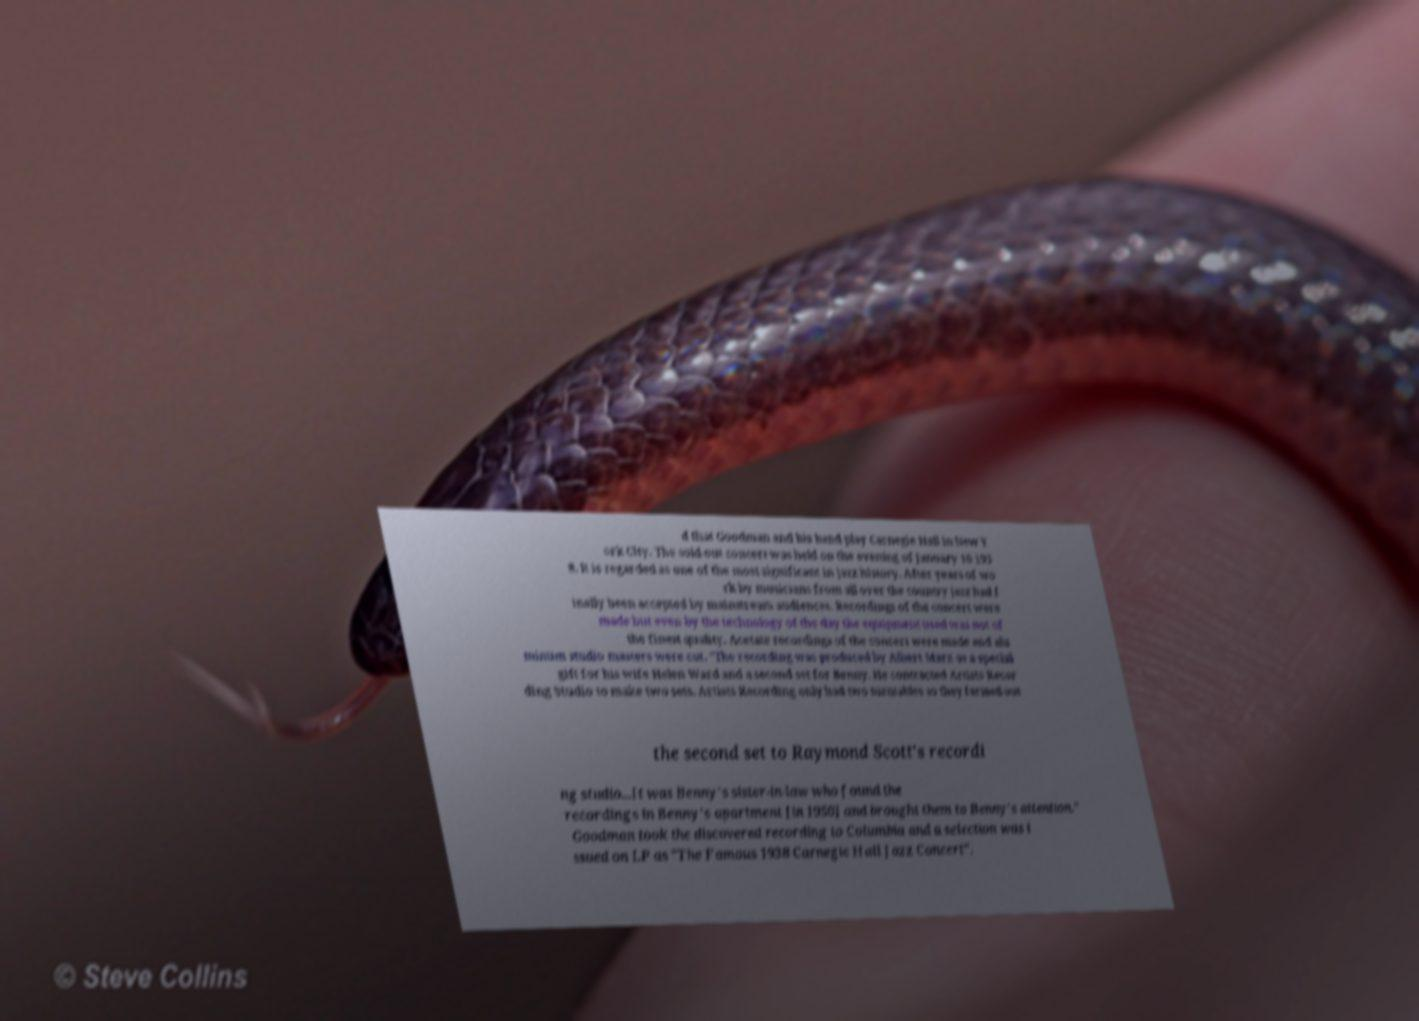There's text embedded in this image that I need extracted. Can you transcribe it verbatim? d that Goodman and his band play Carnegie Hall in New Y ork City. The sold-out concert was held on the evening of January 16 193 8. It is regarded as one of the most significant in jazz history. After years of wo rk by musicians from all over the country jazz had f inally been accepted by mainstream audiences. Recordings of the concert were made but even by the technology of the day the equipment used was not of the finest quality. Acetate recordings of the concert were made and alu minum studio masters were cut. "The recording was produced by Albert Marx as a special gift for his wife Helen Ward and a second set for Benny. He contracted Artists Recor ding Studio to make two sets. Artists Recording only had two turntables so they farmed out the second set to Raymond Scott's recordi ng studio...It was Benny's sister-in-law who found the recordings in Benny's apartment [in 1950] and brought them to Benny's attention." Goodman took the discovered recording to Columbia and a selection was i ssued on LP as "The Famous 1938 Carnegie Hall Jazz Concert". 